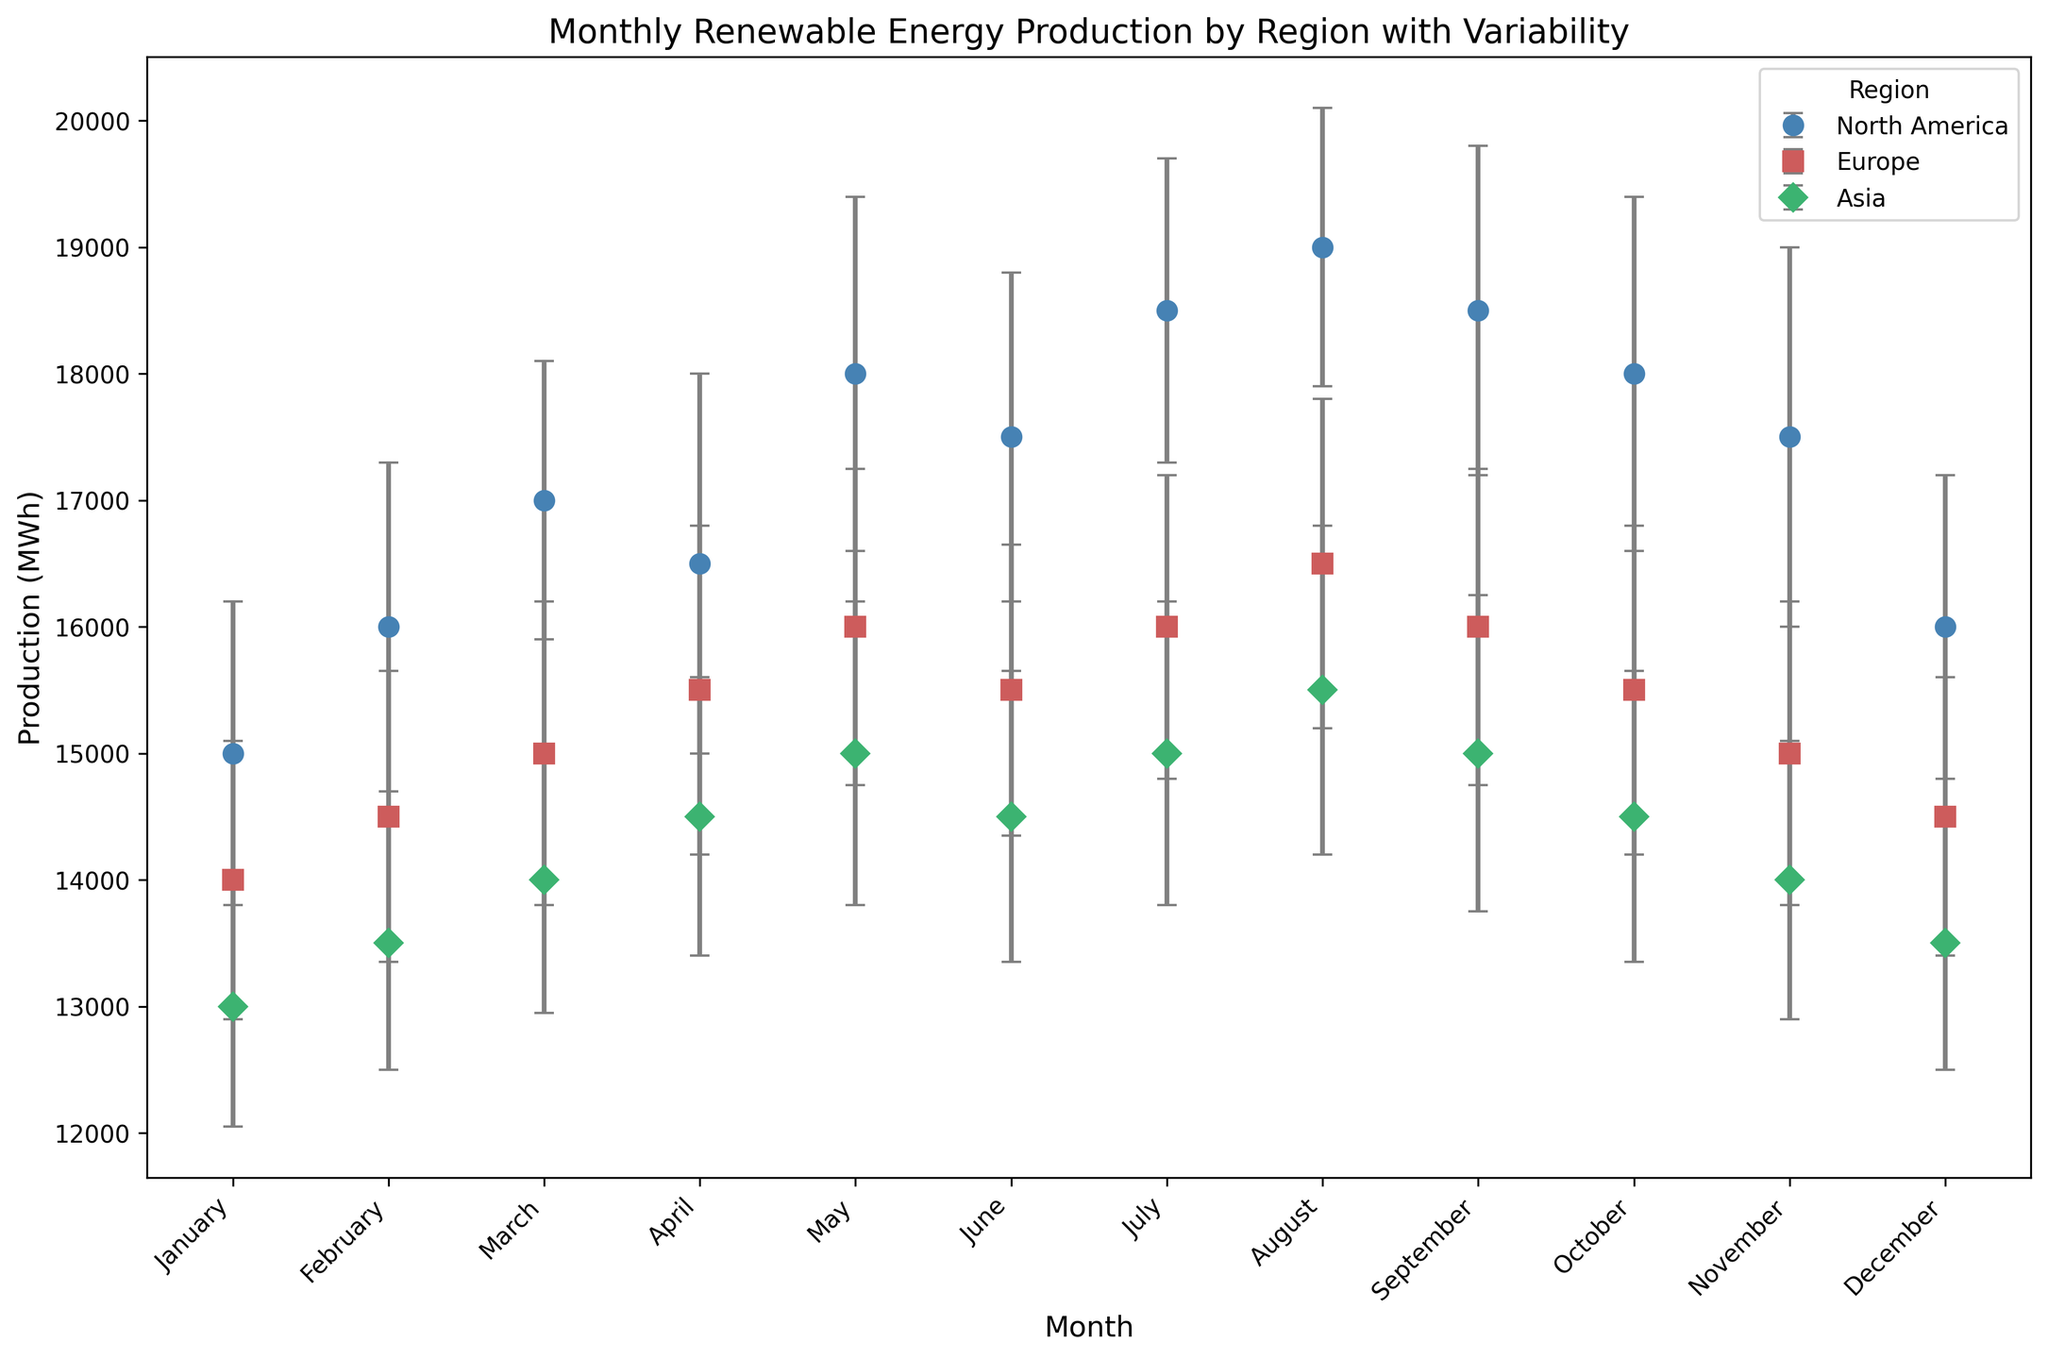Which region has the highest average monthly renewable energy production in July? The figure displays the average production values for each region. By examining July's values, North America has an average production of 18,500 MWh, which is higher than both Europe (16,000 MWh) and Asia (15,000 MWh).
Answer: North America Which month has the lowest average production in Asia? By checking the data points for each month in Asia, the lowest value is in January, with an average production of 13,000 MWh.
Answer: January Compare the standard deviation in renewable energy production in May for North America and Asia. Which is higher? The figure shows error bars representing standard deviations. For May, North America's standard deviation is 1,400 MWh, while Asia's is 1,200 MWh. Thus, North America's value is higher.
Answer: North America How does the average production in April compare between Europe and North America? In April, Europe has an average production of 15,500 MWh, while North America has 16,500 MWh. Therefore, North America's production is higher.
Answer: North America What is the total average production in North America for the first quarter of the year? Summing the average production for January (15,000 MWh), February (16,000 MWh), and March (17,000 MWh) gives the total production for the first quarter as 15,000 + 16,000 + 17,000 = 48,000 MWh.
Answer: 48,000 MWh Which region shows the most variability in renewable energy production in August? The error bars (representing standard deviation) indicate variability. In August, North America has a standard deviation of 1,100 MWh, Europe has 1,300 MWh, and Asia has 1,300 MWh. Europe and Asia both have the highest variability.
Answer: Europe and Asia In which month does Europe have the highest average production? Observing Europe's data points across the months, the highest average production is in August with 16,500 MWh.
Answer: August Does North America or Asia have a higher average production in December? By looking at December values: North America has 16,000 MWh and Asia has 13,500 MWh. North America’s production is higher.
Answer: North America What is the difference in average production between May and June in Europe? Europe's average production in May is 16,000 MWh and in June is 15,500 MWh. The difference is 16,000 - 15,500 = 500 MWh.
Answer: 500 MWh How does the average production in February compare between all three regions? The values for February are: North America 16,000 MWh, Europe 14,500 MWh, Asia 13,500 MWh. North America has the highest production, followed by Europe, then Asia.
Answer: North America, Europe, Asia 